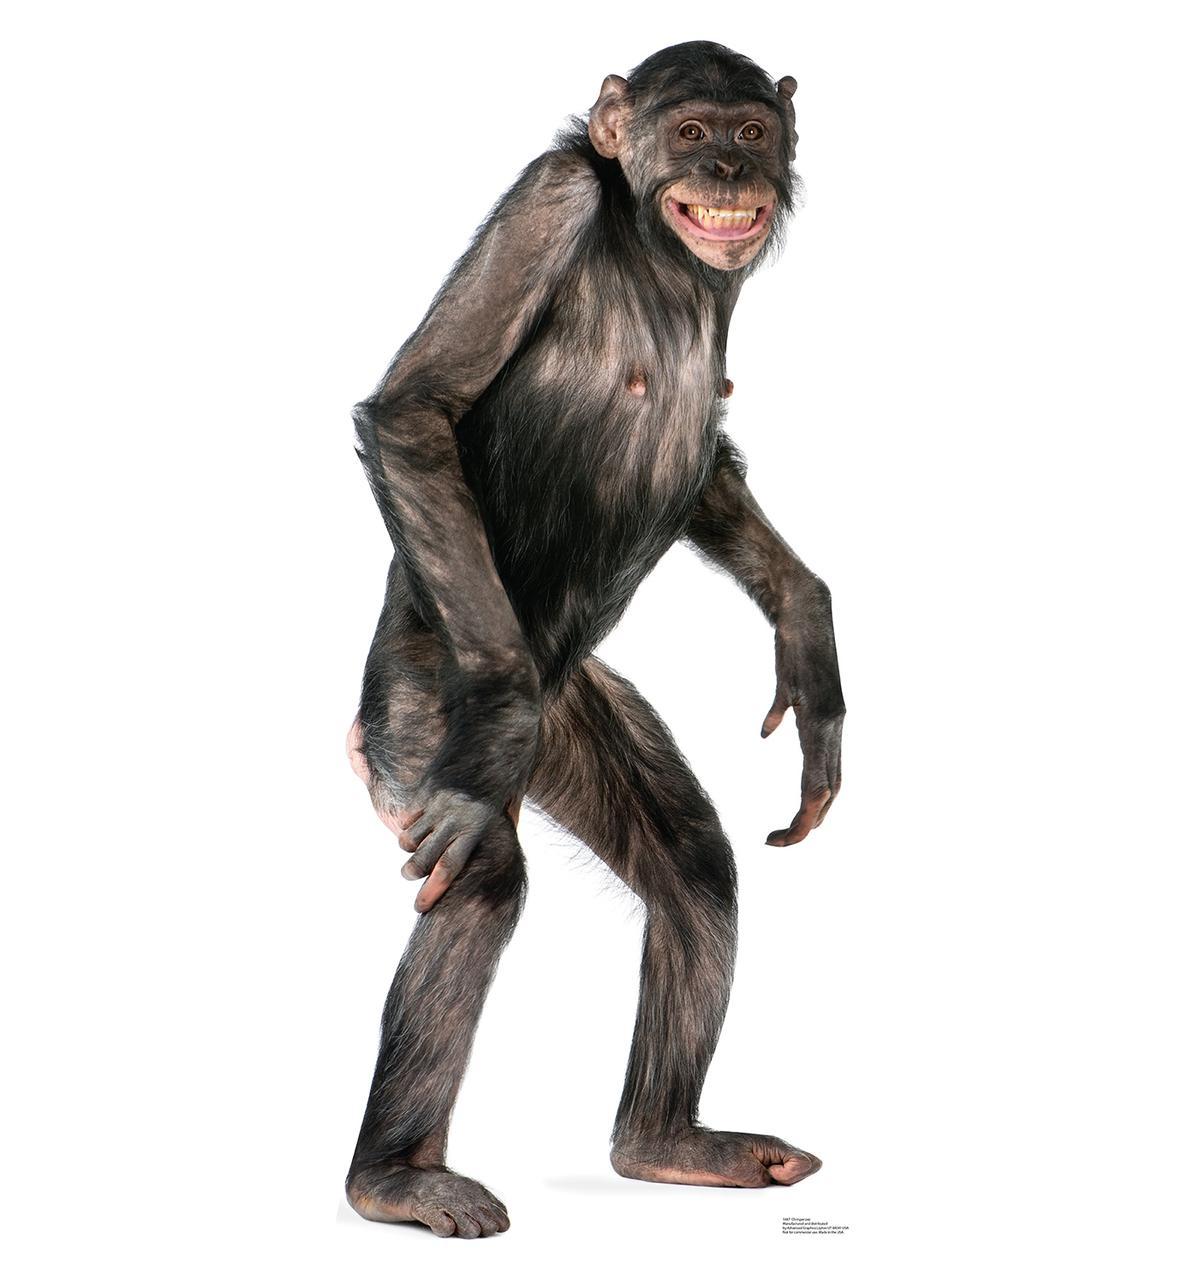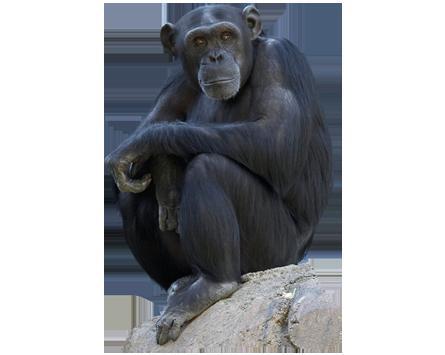The first image is the image on the left, the second image is the image on the right. Considering the images on both sides, is "One chimp is standing on four feet." valid? Answer yes or no. No. The first image is the image on the left, the second image is the image on the right. Given the left and right images, does the statement "In one of the images a monkey is on all four legs." hold true? Answer yes or no. No. 